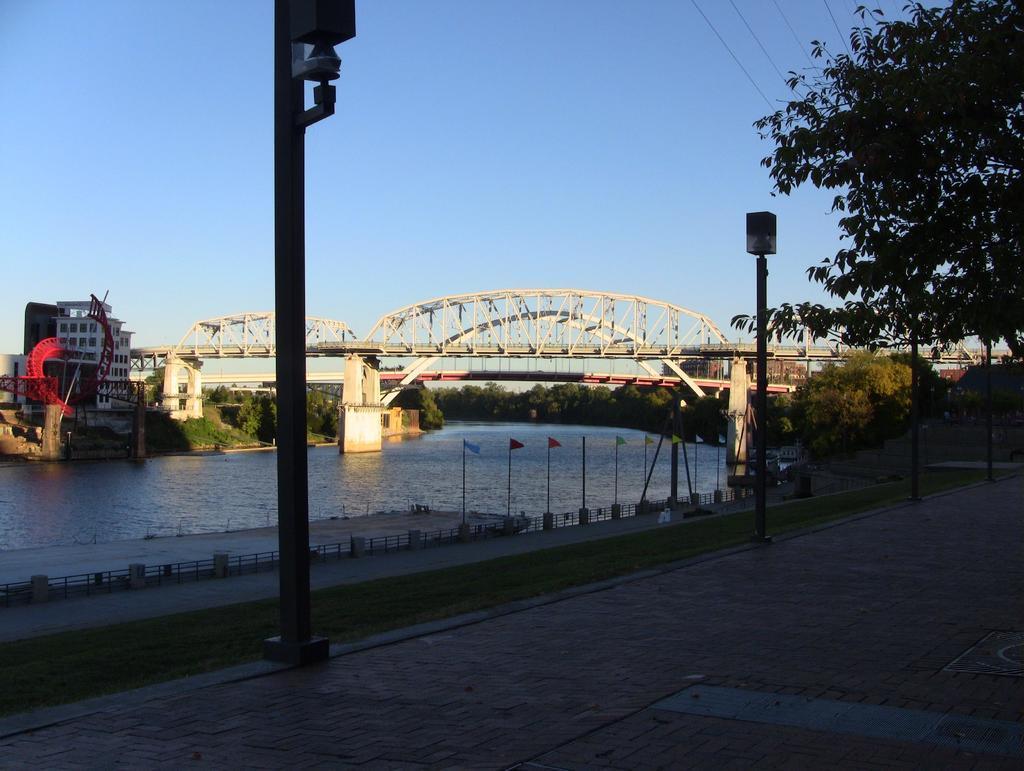In one or two sentences, can you explain what this image depicts? In the foreground of the picture I can see the decorative light poles. In the background, I can see the lake and bridge. I can see the flag poles on the side of the lake. In the background, I can see the buildings and trees. I can see the electric wires on the top right side. There are clouds in the sky. 